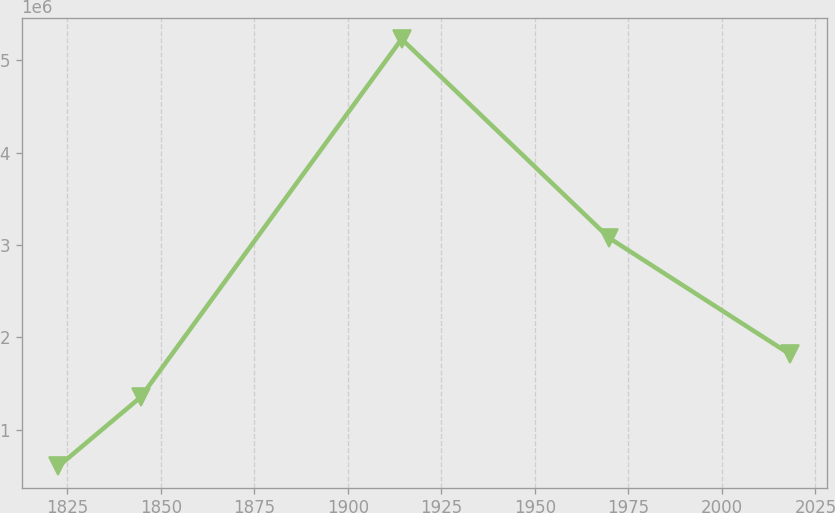Convert chart to OTSL. <chart><loc_0><loc_0><loc_500><loc_500><line_chart><ecel><fcel>Unnamed: 1<nl><fcel>1822.56<fcel>601184<nl><fcel>1844.59<fcel>1.35134e+06<nl><fcel>1914.38<fcel>5.23082e+06<nl><fcel>1969.89<fcel>3.07554e+06<nl><fcel>2018.31<fcel>1.81431e+06<nl></chart> 